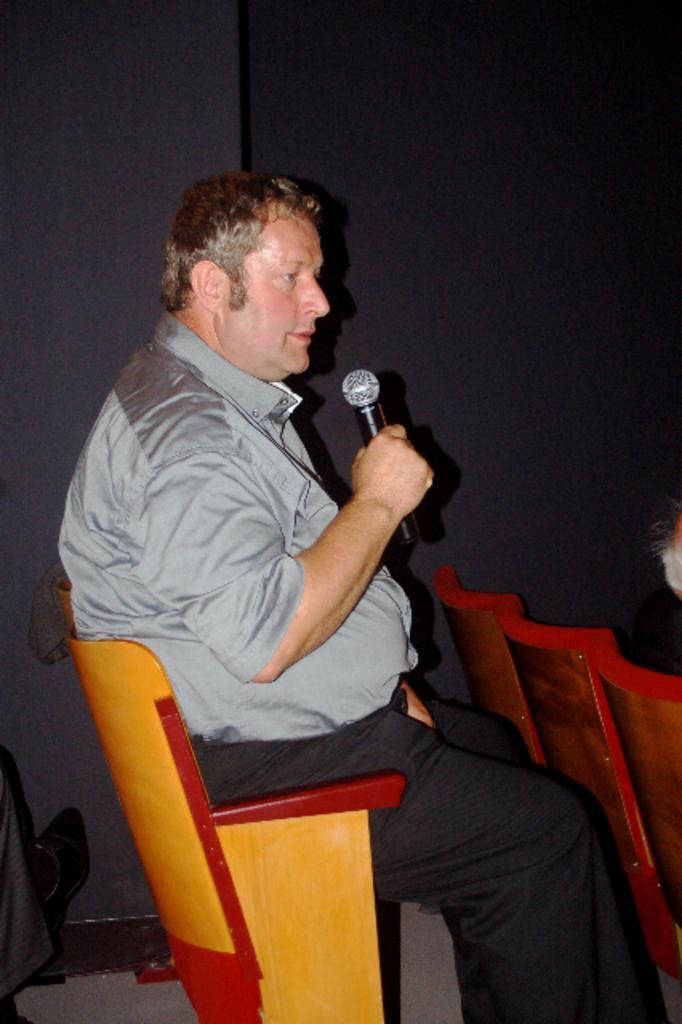Please provide a concise description of this image. In this image, There is a chair which is in yellow color there is a man sitting on the chair and he is holding a microphone and he is speaking in the microphone, There are some chairs which are in yellow color, In the background there is a black color wall. 